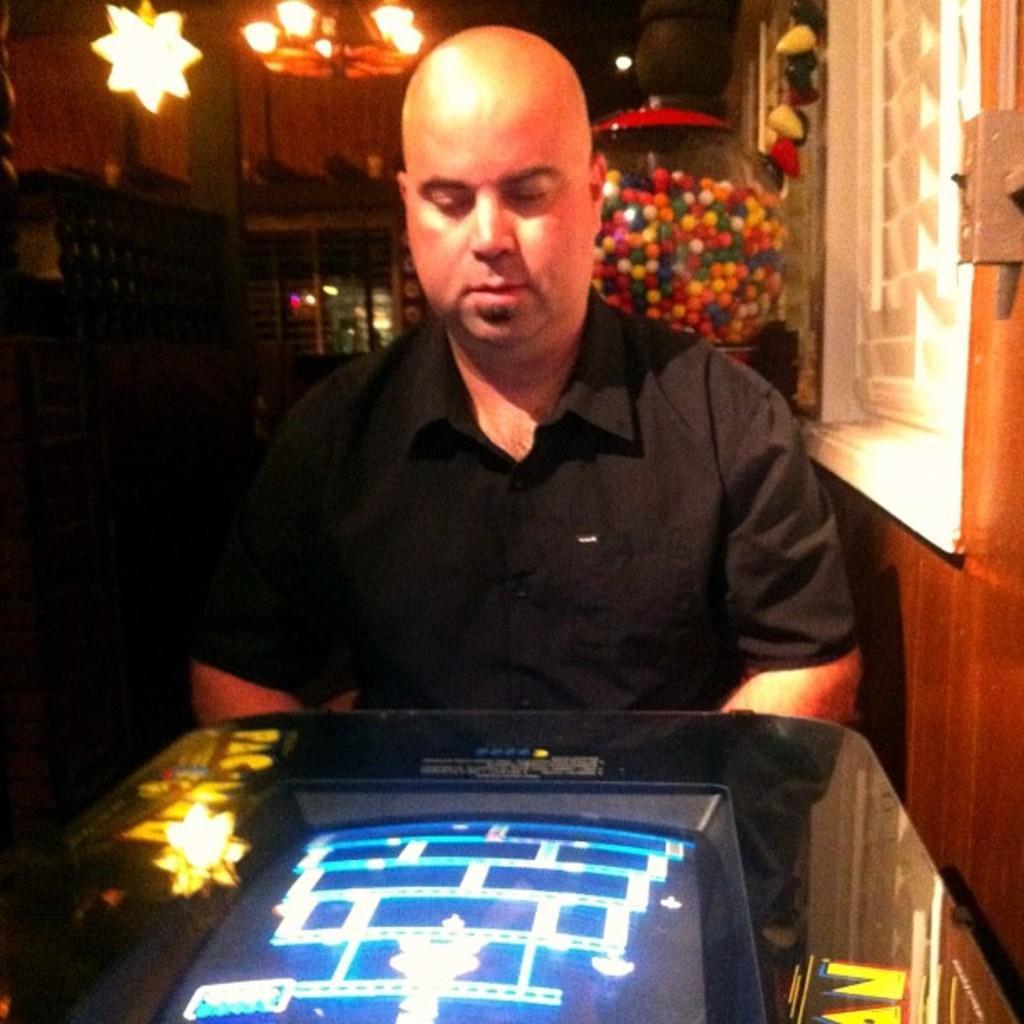Please provide a concise description of this image. In this image I can see a person wearing black color dress. In front I can see a screen. Back I can see few lights and a glass pot. We can see few ball in the pot. 